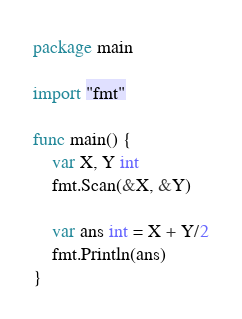<code> <loc_0><loc_0><loc_500><loc_500><_Go_>package main

import "fmt"

func main() {
	var X, Y int
	fmt.Scan(&X, &Y)

	var ans int = X + Y/2
	fmt.Println(ans)
}
</code> 